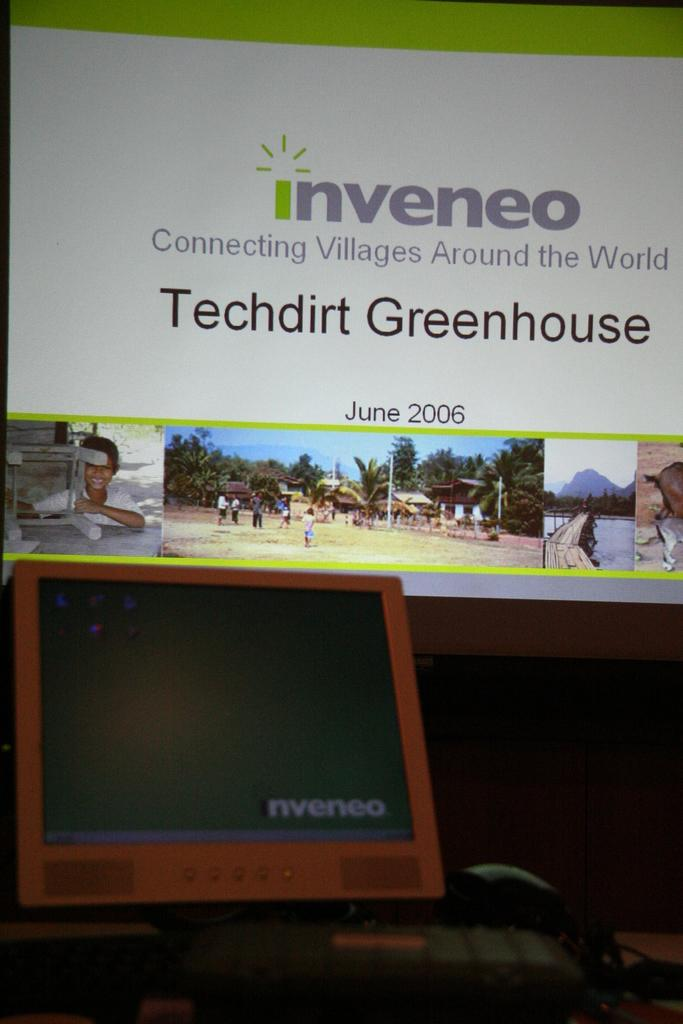<image>
Give a short and clear explanation of the subsequent image. A digital advertisement for Inveneo dated June 2006 and displayed over top of another electronic. 